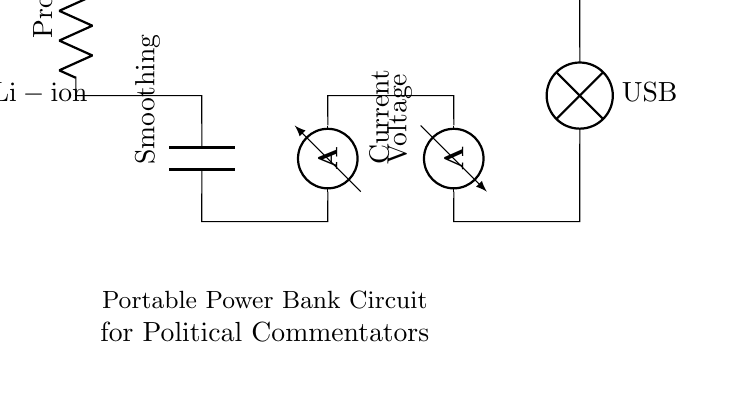What type of battery is used in this circuit? The circuit diagram indicates the presence of a battery labeled as "Li-ion". This is a common type of rechargeable battery used in portable electronic devices.
Answer: Li-ion What component provides voltage regulation in this circuit? The protection component is essential for voltage regulation and safety in the circuit, safeguarding against overvoltage and overcurrent, ensuring that the connected devices receive a stable voltage.
Answer: Protection What is the purpose of the smoothing capacitor in this circuit? The smoothing capacitor is used to reduce voltage fluctuations after the battery's output, providing a stable voltage, which is crucial for the reliable operation of USB-powered devices that may be sensitive to changes in voltage.
Answer: Smoothing How many measurement devices are in this circuit? There are two measurement devices in the circuit: an ammeter for current measurement and a voltmeter for voltage measurement. The presence of these devices allows the user to monitor the performance of the power bank.
Answer: Two What is the output interface of this power bank? The circuit shows a lamp labeled "USB" which indicates that the output interface of the power bank is a USB connection, commonly used for charging and powering devices like smartphones and tablets.
Answer: USB What is the role of the ammeter? The ammeter is used to measure the current flowing through the circuit, allowing users to monitor how much current is being drawn by the device connected to the power bank, which is crucial for ensuring safe operation within the limits of the battery.
Answer: Measure current 